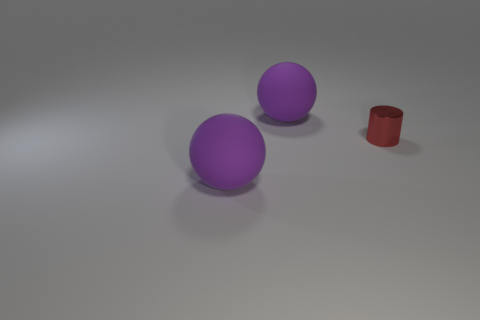Add 1 large balls. How many objects exist? 4 Subtract all balls. How many objects are left? 1 Subtract 1 balls. How many balls are left? 1 Add 2 spheres. How many spheres are left? 4 Add 2 gray rubber balls. How many gray rubber balls exist? 2 Subtract 0 cyan cylinders. How many objects are left? 3 Subtract all purple cylinders. Subtract all green cubes. How many cylinders are left? 1 Subtract all big brown matte cylinders. Subtract all red cylinders. How many objects are left? 2 